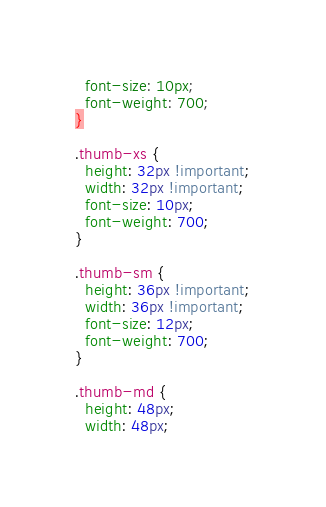Convert code to text. <code><loc_0><loc_0><loc_500><loc_500><_CSS_>  font-size: 10px;
  font-weight: 700;
}

.thumb-xs {
  height: 32px !important;
  width: 32px !important;
  font-size: 10px;
  font-weight: 700;
}

.thumb-sm {
  height: 36px !important;
  width: 36px !important;
  font-size: 12px;
  font-weight: 700;
}

.thumb-md {
  height: 48px;
  width: 48px;</code> 